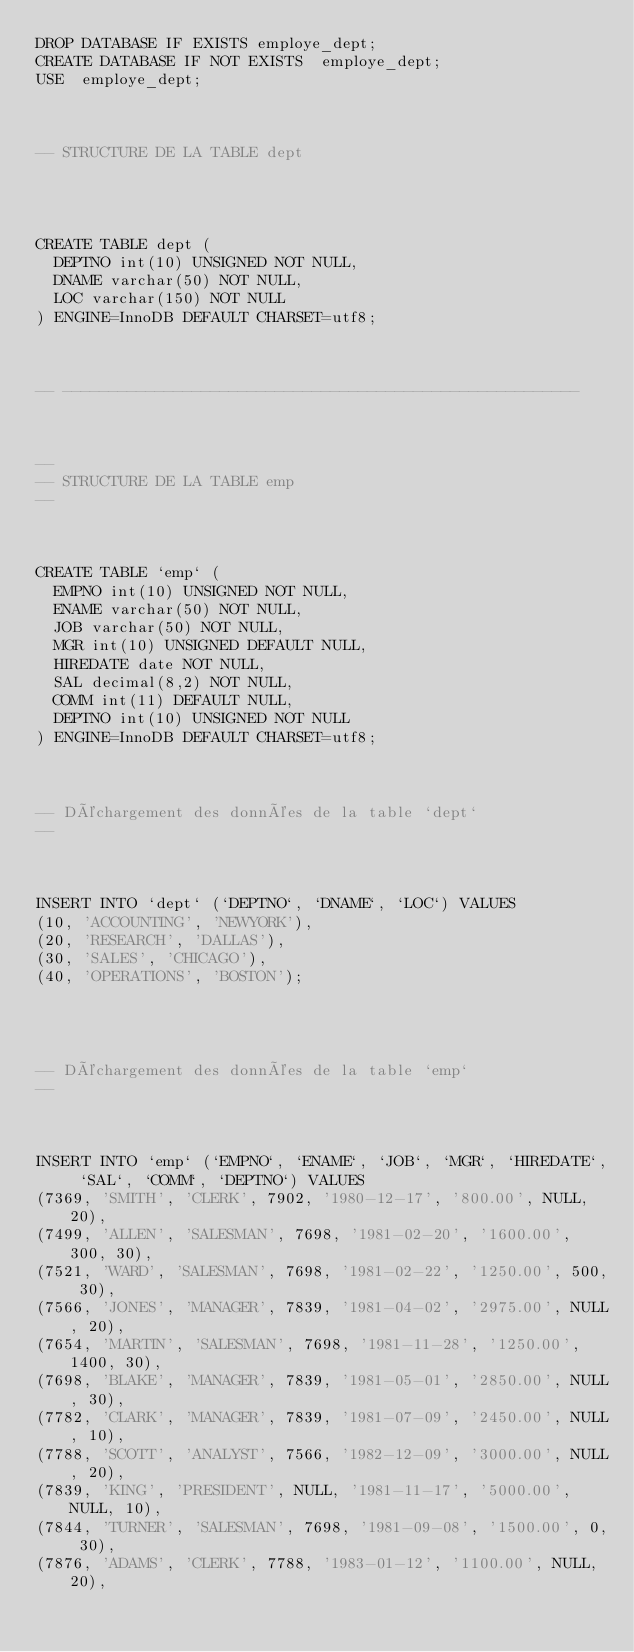Convert code to text. <code><loc_0><loc_0><loc_500><loc_500><_SQL_>DROP DATABASE IF EXISTS employe_dept;
CREATE DATABASE IF NOT EXISTS  employe_dept;
USE  employe_dept;

 

-- STRUCTURE DE LA TABLE dept

 


CREATE TABLE dept (
  DEPTNO int(10) UNSIGNED NOT NULL,
  DNAME varchar(50) NOT NULL,
  LOC varchar(150) NOT NULL
) ENGINE=InnoDB DEFAULT CHARSET=utf8;

 

-- --------------------------------------------------------

 

--
-- STRUCTURE DE LA TABLE emp
--

 

CREATE TABLE `emp` (
  EMPNO int(10) UNSIGNED NOT NULL,
  ENAME varchar(50) NOT NULL,
  JOB varchar(50) NOT NULL,
  MGR int(10) UNSIGNED DEFAULT NULL,
  HIREDATE date NOT NULL,
  SAL decimal(8,2) NOT NULL,
  COMM int(11) DEFAULT NULL,
  DEPTNO int(10) UNSIGNED NOT NULL
) ENGINE=InnoDB DEFAULT CHARSET=utf8;

 

-- Déchargement des données de la table `dept`
--

 

INSERT INTO `dept` (`DEPTNO`, `DNAME`, `LOC`) VALUES
(10, 'ACCOUNTING', 'NEWYORK'),
(20, 'RESEARCH', 'DALLAS'),
(30, 'SALES', 'CHICAGO'),
(40, 'OPERATIONS', 'BOSTON');

 


-- Déchargement des données de la table `emp`
--

 

INSERT INTO `emp` (`EMPNO`, `ENAME`, `JOB`, `MGR`, `HIREDATE`, `SAL`, `COMM`, `DEPTNO`) VALUES
(7369, 'SMITH', 'CLERK', 7902, '1980-12-17', '800.00', NULL, 20),
(7499, 'ALLEN', 'SALESMAN', 7698, '1981-02-20', '1600.00', 300, 30),
(7521, 'WARD', 'SALESMAN', 7698, '1981-02-22', '1250.00', 500, 30),
(7566, 'JONES', 'MANAGER', 7839, '1981-04-02', '2975.00', NULL, 20),
(7654, 'MARTIN', 'SALESMAN', 7698, '1981-11-28', '1250.00', 1400, 30),
(7698, 'BLAKE', 'MANAGER', 7839, '1981-05-01', '2850.00', NULL, 30),
(7782, 'CLARK', 'MANAGER', 7839, '1981-07-09', '2450.00', NULL, 10),
(7788, 'SCOTT', 'ANALYST', 7566, '1982-12-09', '3000.00', NULL, 20),
(7839, 'KING', 'PRESIDENT', NULL, '1981-11-17', '5000.00', NULL, 10),
(7844, 'TURNER', 'SALESMAN', 7698, '1981-09-08', '1500.00', 0, 30),
(7876, 'ADAMS', 'CLERK', 7788, '1983-01-12', '1100.00', NULL, 20),</code> 